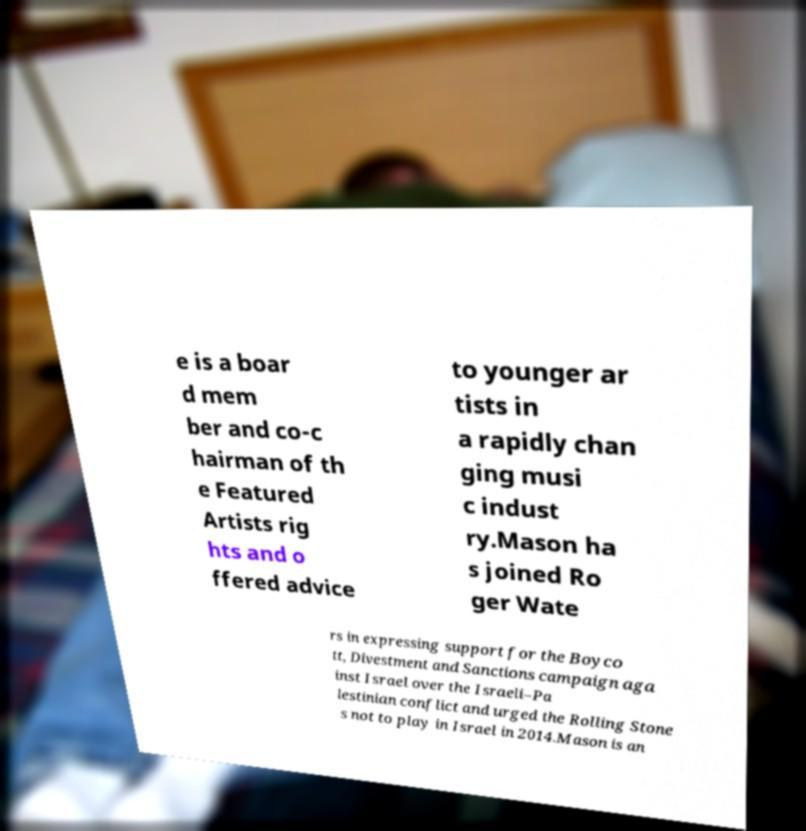I need the written content from this picture converted into text. Can you do that? e is a boar d mem ber and co-c hairman of th e Featured Artists rig hts and o ffered advice to younger ar tists in a rapidly chan ging musi c indust ry.Mason ha s joined Ro ger Wate rs in expressing support for the Boyco tt, Divestment and Sanctions campaign aga inst Israel over the Israeli–Pa lestinian conflict and urged the Rolling Stone s not to play in Israel in 2014.Mason is an 